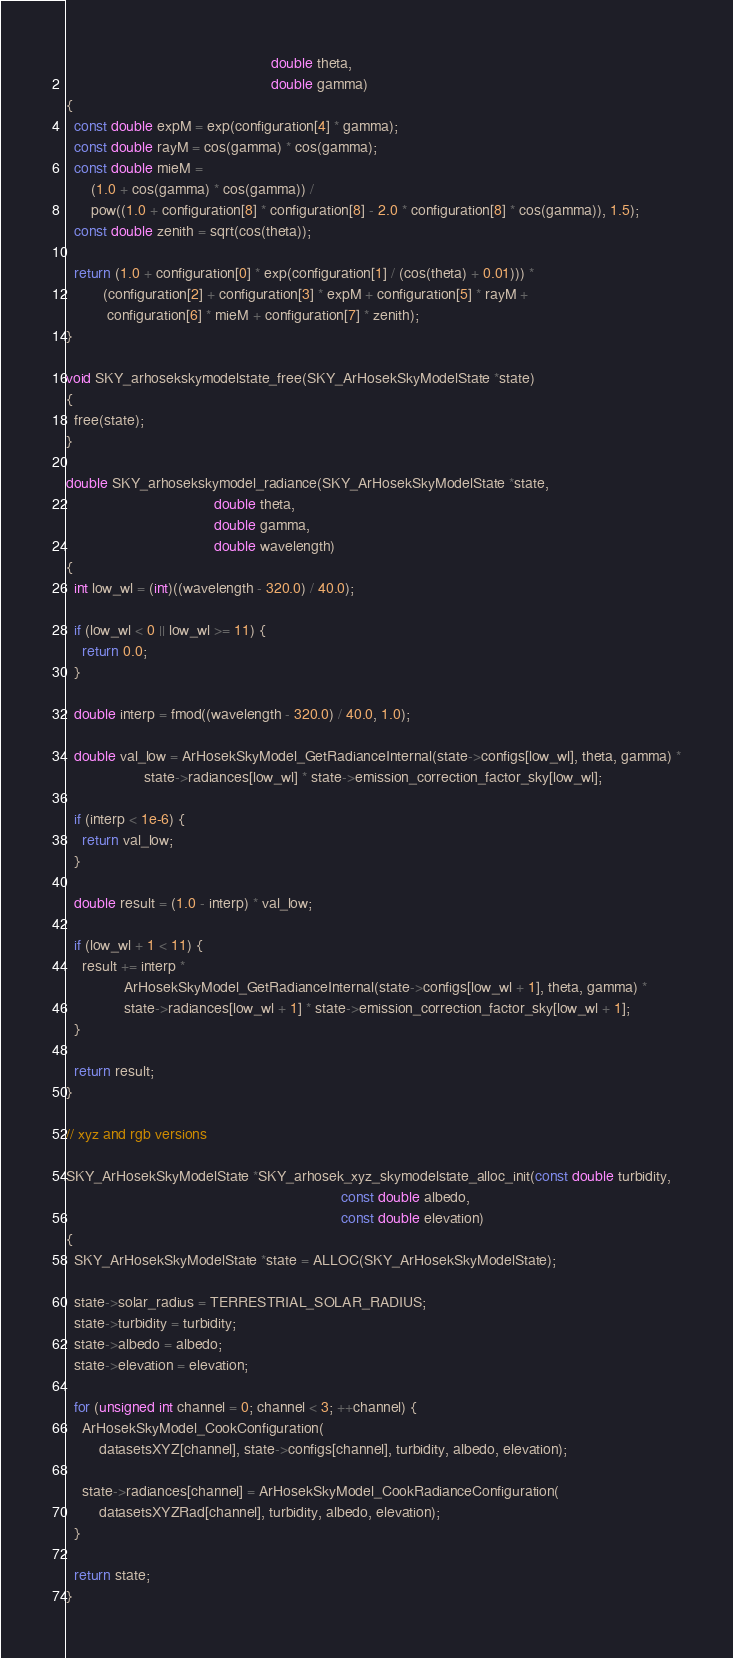Convert code to text. <code><loc_0><loc_0><loc_500><loc_500><_C++_>                                                  double theta,
                                                  double gamma)
{
  const double expM = exp(configuration[4] * gamma);
  const double rayM = cos(gamma) * cos(gamma);
  const double mieM =
      (1.0 + cos(gamma) * cos(gamma)) /
      pow((1.0 + configuration[8] * configuration[8] - 2.0 * configuration[8] * cos(gamma)), 1.5);
  const double zenith = sqrt(cos(theta));

  return (1.0 + configuration[0] * exp(configuration[1] / (cos(theta) + 0.01))) *
         (configuration[2] + configuration[3] * expM + configuration[5] * rayM +
          configuration[6] * mieM + configuration[7] * zenith);
}

void SKY_arhosekskymodelstate_free(SKY_ArHosekSkyModelState *state)
{
  free(state);
}

double SKY_arhosekskymodel_radiance(SKY_ArHosekSkyModelState *state,
                                    double theta,
                                    double gamma,
                                    double wavelength)
{
  int low_wl = (int)((wavelength - 320.0) / 40.0);

  if (low_wl < 0 || low_wl >= 11) {
    return 0.0;
  }

  double interp = fmod((wavelength - 320.0) / 40.0, 1.0);

  double val_low = ArHosekSkyModel_GetRadianceInternal(state->configs[low_wl], theta, gamma) *
                   state->radiances[low_wl] * state->emission_correction_factor_sky[low_wl];

  if (interp < 1e-6) {
    return val_low;
  }

  double result = (1.0 - interp) * val_low;

  if (low_wl + 1 < 11) {
    result += interp *
              ArHosekSkyModel_GetRadianceInternal(state->configs[low_wl + 1], theta, gamma) *
              state->radiances[low_wl + 1] * state->emission_correction_factor_sky[low_wl + 1];
  }

  return result;
}

// xyz and rgb versions

SKY_ArHosekSkyModelState *SKY_arhosek_xyz_skymodelstate_alloc_init(const double turbidity,
                                                                   const double albedo,
                                                                   const double elevation)
{
  SKY_ArHosekSkyModelState *state = ALLOC(SKY_ArHosekSkyModelState);

  state->solar_radius = TERRESTRIAL_SOLAR_RADIUS;
  state->turbidity = turbidity;
  state->albedo = albedo;
  state->elevation = elevation;

  for (unsigned int channel = 0; channel < 3; ++channel) {
    ArHosekSkyModel_CookConfiguration(
        datasetsXYZ[channel], state->configs[channel], turbidity, albedo, elevation);

    state->radiances[channel] = ArHosekSkyModel_CookRadianceConfiguration(
        datasetsXYZRad[channel], turbidity, albedo, elevation);
  }

  return state;
}
</code> 